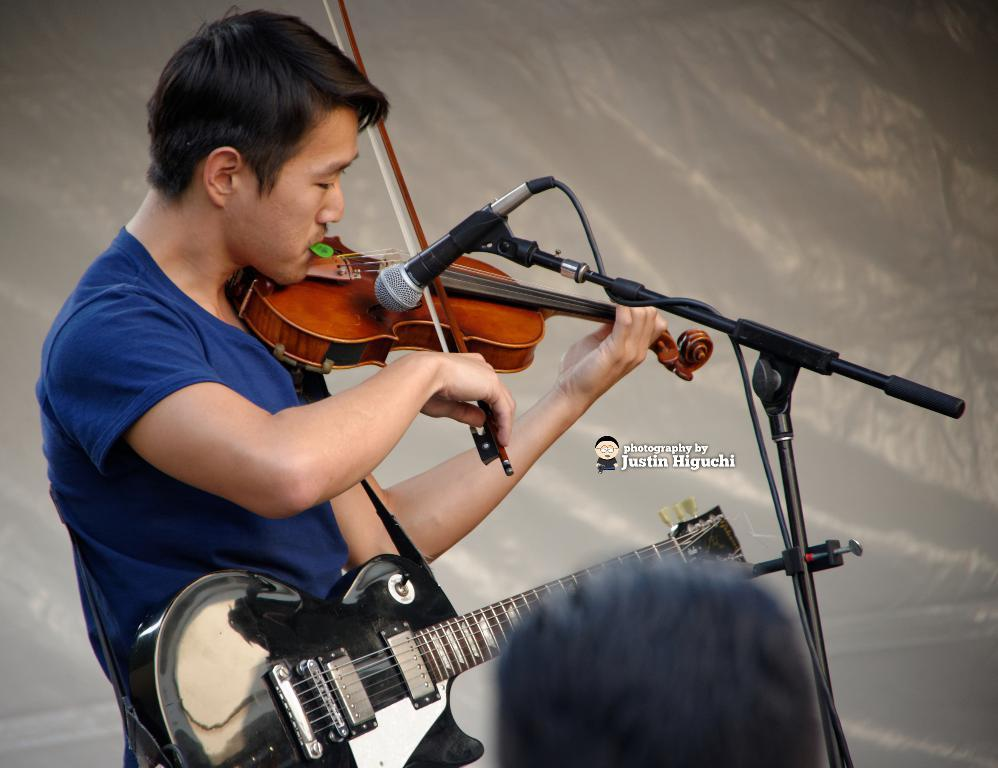What is the main subject of the image? There is a person in the image. What is the person doing in the image? The person is standing and playing the violin. What instrument is the person holding in the image? The person is holding a guitar. What equipment is present in the image for amplifying sound? There is a microphone with a stand in the image. What type of furniture can be seen in the image? There is no furniture present in the image. How many quartz crystals are visible in the image? There are no quartz crystals present in the image. 